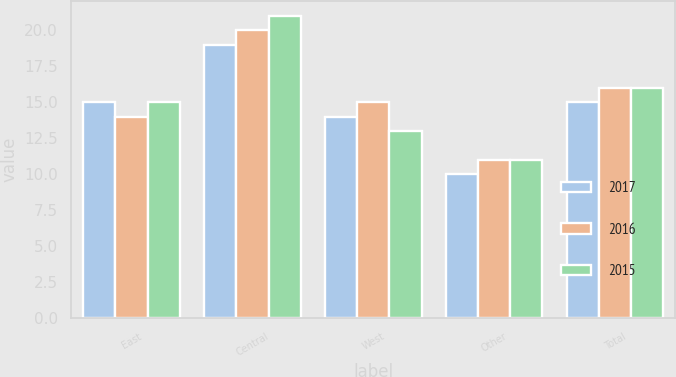Convert chart. <chart><loc_0><loc_0><loc_500><loc_500><stacked_bar_chart><ecel><fcel>East<fcel>Central<fcel>West<fcel>Other<fcel>Total<nl><fcel>2017<fcel>15<fcel>19<fcel>14<fcel>10<fcel>15<nl><fcel>2016<fcel>14<fcel>20<fcel>15<fcel>11<fcel>16<nl><fcel>2015<fcel>15<fcel>21<fcel>13<fcel>11<fcel>16<nl></chart> 